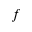<formula> <loc_0><loc_0><loc_500><loc_500>f</formula> 